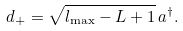<formula> <loc_0><loc_0><loc_500><loc_500>d _ { + } = \sqrt { l _ { \max } - L + 1 } \, a ^ { \dagger } .</formula> 